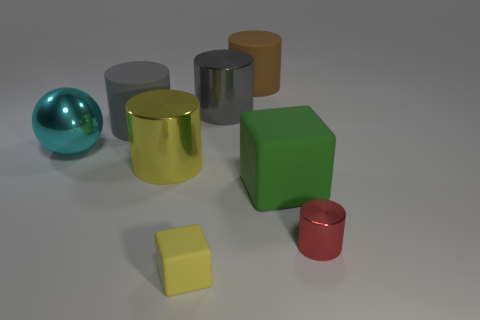What number of brown objects are there?
Give a very brief answer. 1. Are there fewer yellow cylinders on the right side of the brown matte thing than gray cylinders that are right of the large gray rubber object?
Offer a terse response. Yes. Is the number of large yellow cylinders on the right side of the big green cube less than the number of green rubber objects?
Your answer should be compact. Yes. There is a big cylinder in front of the large metallic object that is to the left of the big matte cylinder that is left of the brown object; what is it made of?
Your answer should be compact. Metal. What number of objects are large gray cylinders on the right side of the yellow shiny object or large gray metallic cylinders that are behind the green block?
Provide a short and direct response. 1. What is the material of the small object that is the same shape as the large yellow metal object?
Ensure brevity in your answer.  Metal. How many rubber objects are purple cylinders or brown objects?
Offer a very short reply. 1. There is a gray thing that is the same material as the tiny red object; what shape is it?
Your response must be concise. Cylinder. What number of brown things are the same shape as the red object?
Offer a very short reply. 1. There is a metallic object that is behind the large cyan metallic object; does it have the same shape as the matte thing in front of the small cylinder?
Your response must be concise. No. 